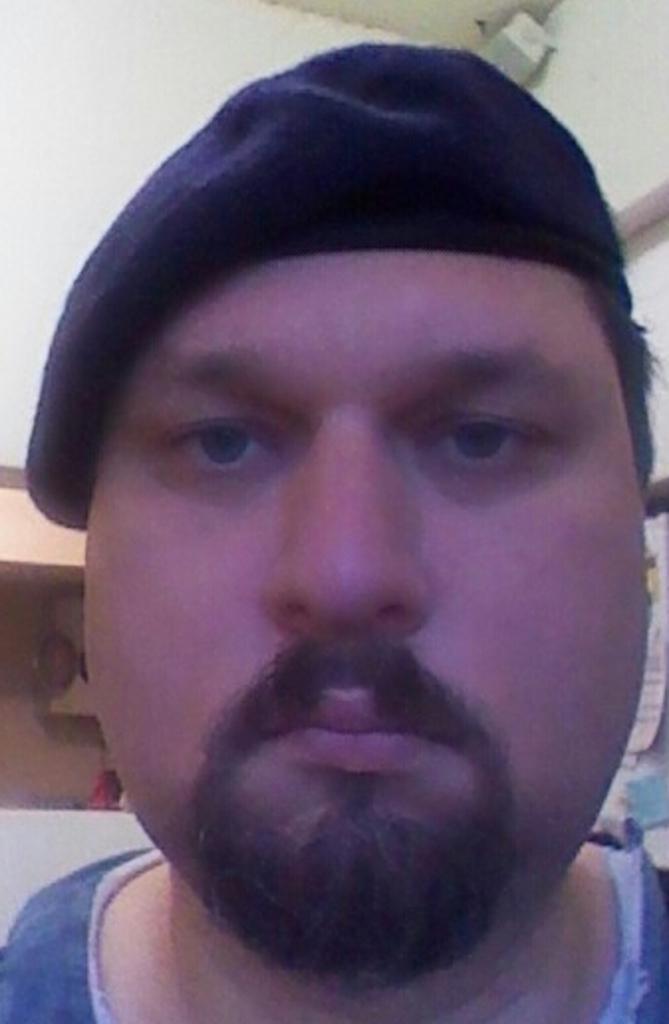In one or two sentences, can you explain what this image depicts? In this picture we can see a man's face in the front, in the background there is a wall, this man wore a cap. 